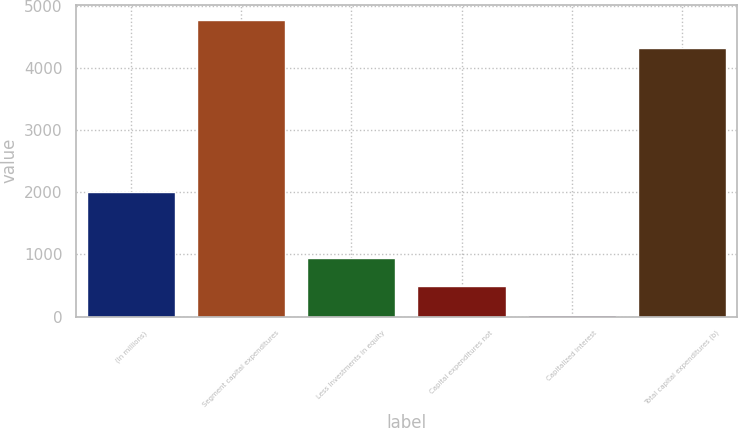Convert chart. <chart><loc_0><loc_0><loc_500><loc_500><bar_chart><fcel>(In millions)<fcel>Segment capital expenditures<fcel>Less Investments in equity<fcel>Capital expenditures not<fcel>Capitalized interest<fcel>Total capital expenditures (b)<nl><fcel>2014<fcel>4785.1<fcel>947.2<fcel>487.1<fcel>27<fcel>4325<nl></chart> 